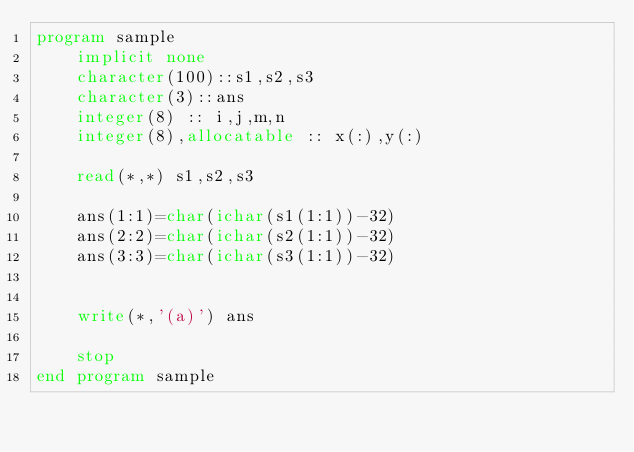Convert code to text. <code><loc_0><loc_0><loc_500><loc_500><_FORTRAN_>program sample
    implicit none
    character(100)::s1,s2,s3
    character(3)::ans
    integer(8) :: i,j,m,n
    integer(8),allocatable :: x(:),y(:)
  
    read(*,*) s1,s2,s3
    
    ans(1:1)=char(ichar(s1(1:1))-32)
    ans(2:2)=char(ichar(s2(1:1))-32)
    ans(3:3)=char(ichar(s3(1:1))-32)
    
  
    write(*,'(a)') ans
  
    stop
end program sample
  

</code> 